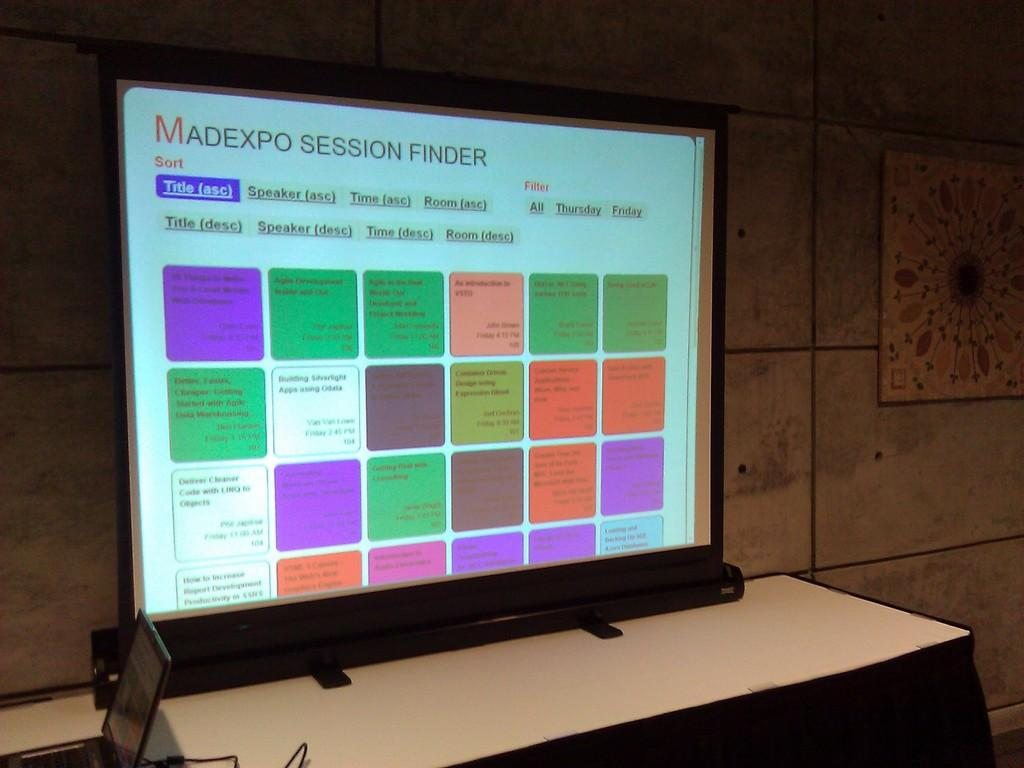<image>
Share a concise interpretation of the image provided. A large table top display for the Madexpo session finder. 